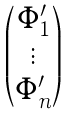<formula> <loc_0><loc_0><loc_500><loc_500>\begin{pmatrix} \Phi ^ { \prime } _ { 1 } \\ \vdots \\ \Phi ^ { \prime } _ { n } \\ \end{pmatrix}</formula> 